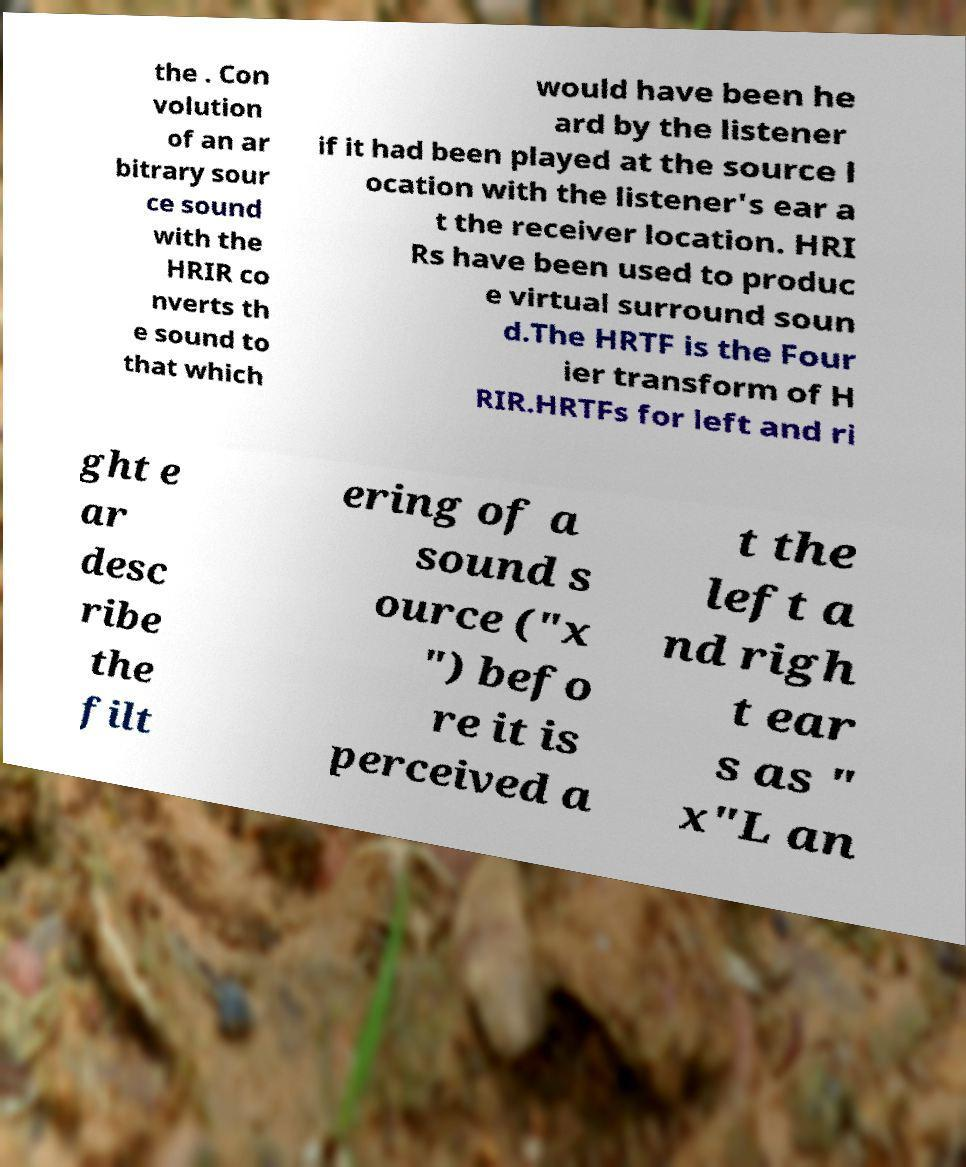There's text embedded in this image that I need extracted. Can you transcribe it verbatim? the . Con volution of an ar bitrary sour ce sound with the HRIR co nverts th e sound to that which would have been he ard by the listener if it had been played at the source l ocation with the listener's ear a t the receiver location. HRI Rs have been used to produc e virtual surround soun d.The HRTF is the Four ier transform of H RIR.HRTFs for left and ri ght e ar desc ribe the filt ering of a sound s ource ("x ") befo re it is perceived a t the left a nd righ t ear s as " x"L an 